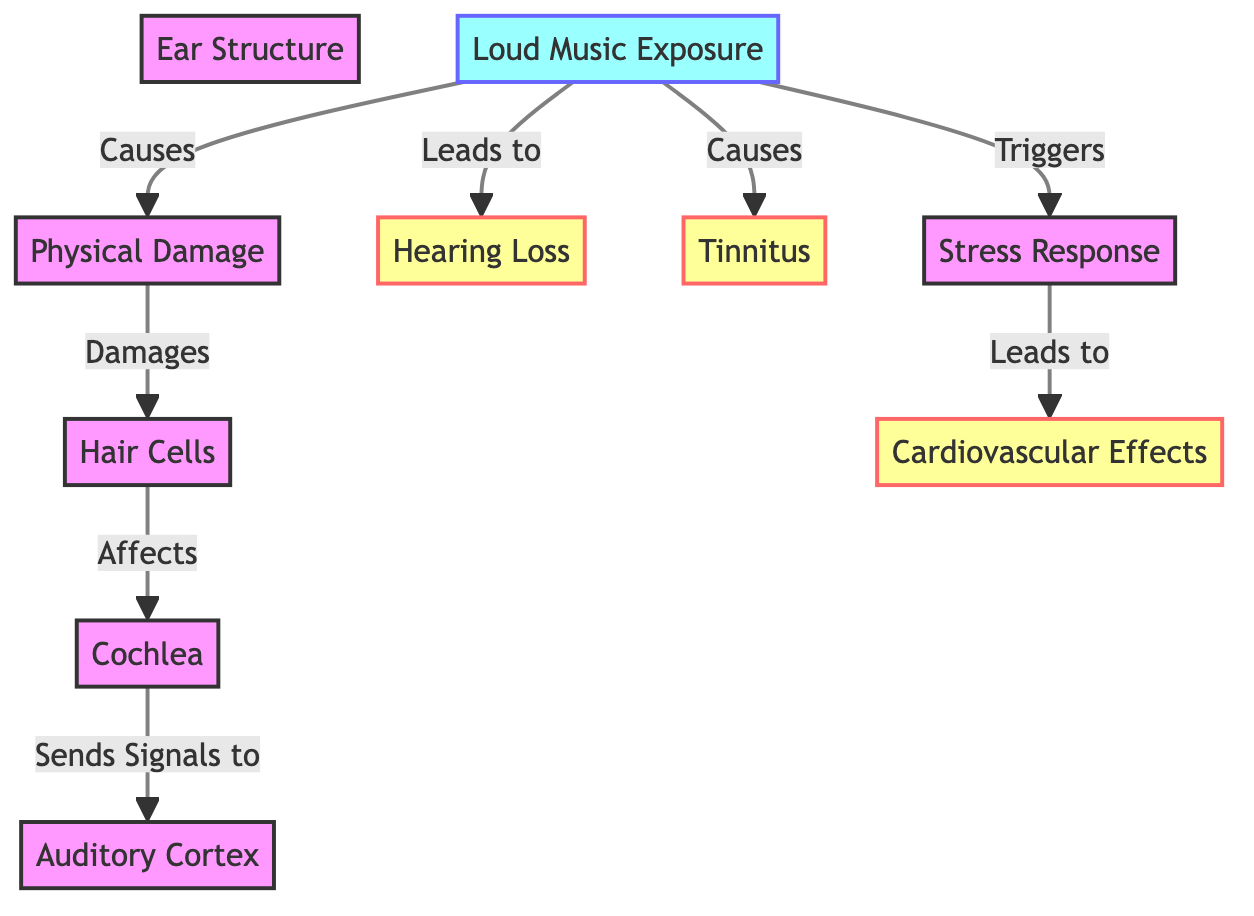What causes physical damage to the hair cells? The diagram indicates that loud music exposure is a direct cause of physical damage, which in turn affects the hair cells. Thus, we look for the arrows pointing to physical damage and identify loud music exposure as the source.
Answer: loud music exposure What effect does loud music exposure have on hearing? The diagram articulates that loud music exposure leads to hearing loss. This is evident from the direct arrow connecting loud music exposure to hearing loss in the diagram.
Answer: hearing loss How many effects are listed in the diagram? By counting the nodes classified as effects (hearing loss, tinnitus, cardiovascular effects), we determine the total number of effects, which is three in this case.
Answer: 3 What triggers the stress response? To find out what triggers the stress response, we look at the connections and find that loud music exposure is indicated as the trigger for stress response. This is shown in the diagram with an arrow pointing from loud music exposure to stress response.
Answer: loud music exposure Which part of the ear is affected by hair cells? The connection in the diagram shows that hair cells damage the cochlea. By identifying the arrow from hair cells to cochlea, we can conclude that the cochlea is the affected part of the ear.
Answer: cochlea How do stress responses affect the cardiovascular system? The diagram illustrates that stress response leads to cardiovascular effects. This requires tracing the connection from stress response to cardiovascular effects, indicating that stress responses have a direct impact on cardiovascular health.
Answer: cardiovascular effects What is the sequence of damage from loud music exposure to brain processing? Following the arrows, we observe that loud music exposure causes physical damage, which damages hair cells. Hair cells then affect the cochlea, and the cochlea sends signals to the auditory cortex in the brain. This sequential flow determines the pathway of damage.
Answer: loud music exposure → physical damage → hair cells → cochlea → auditory cortex What element causes tinnitus? By tracing the flow in the diagram, it is evident that tinnitus is caused directly by loud music exposure, as indicated by the arrow pointing from loud music exposure to tinnitus.
Answer: loud music exposure 